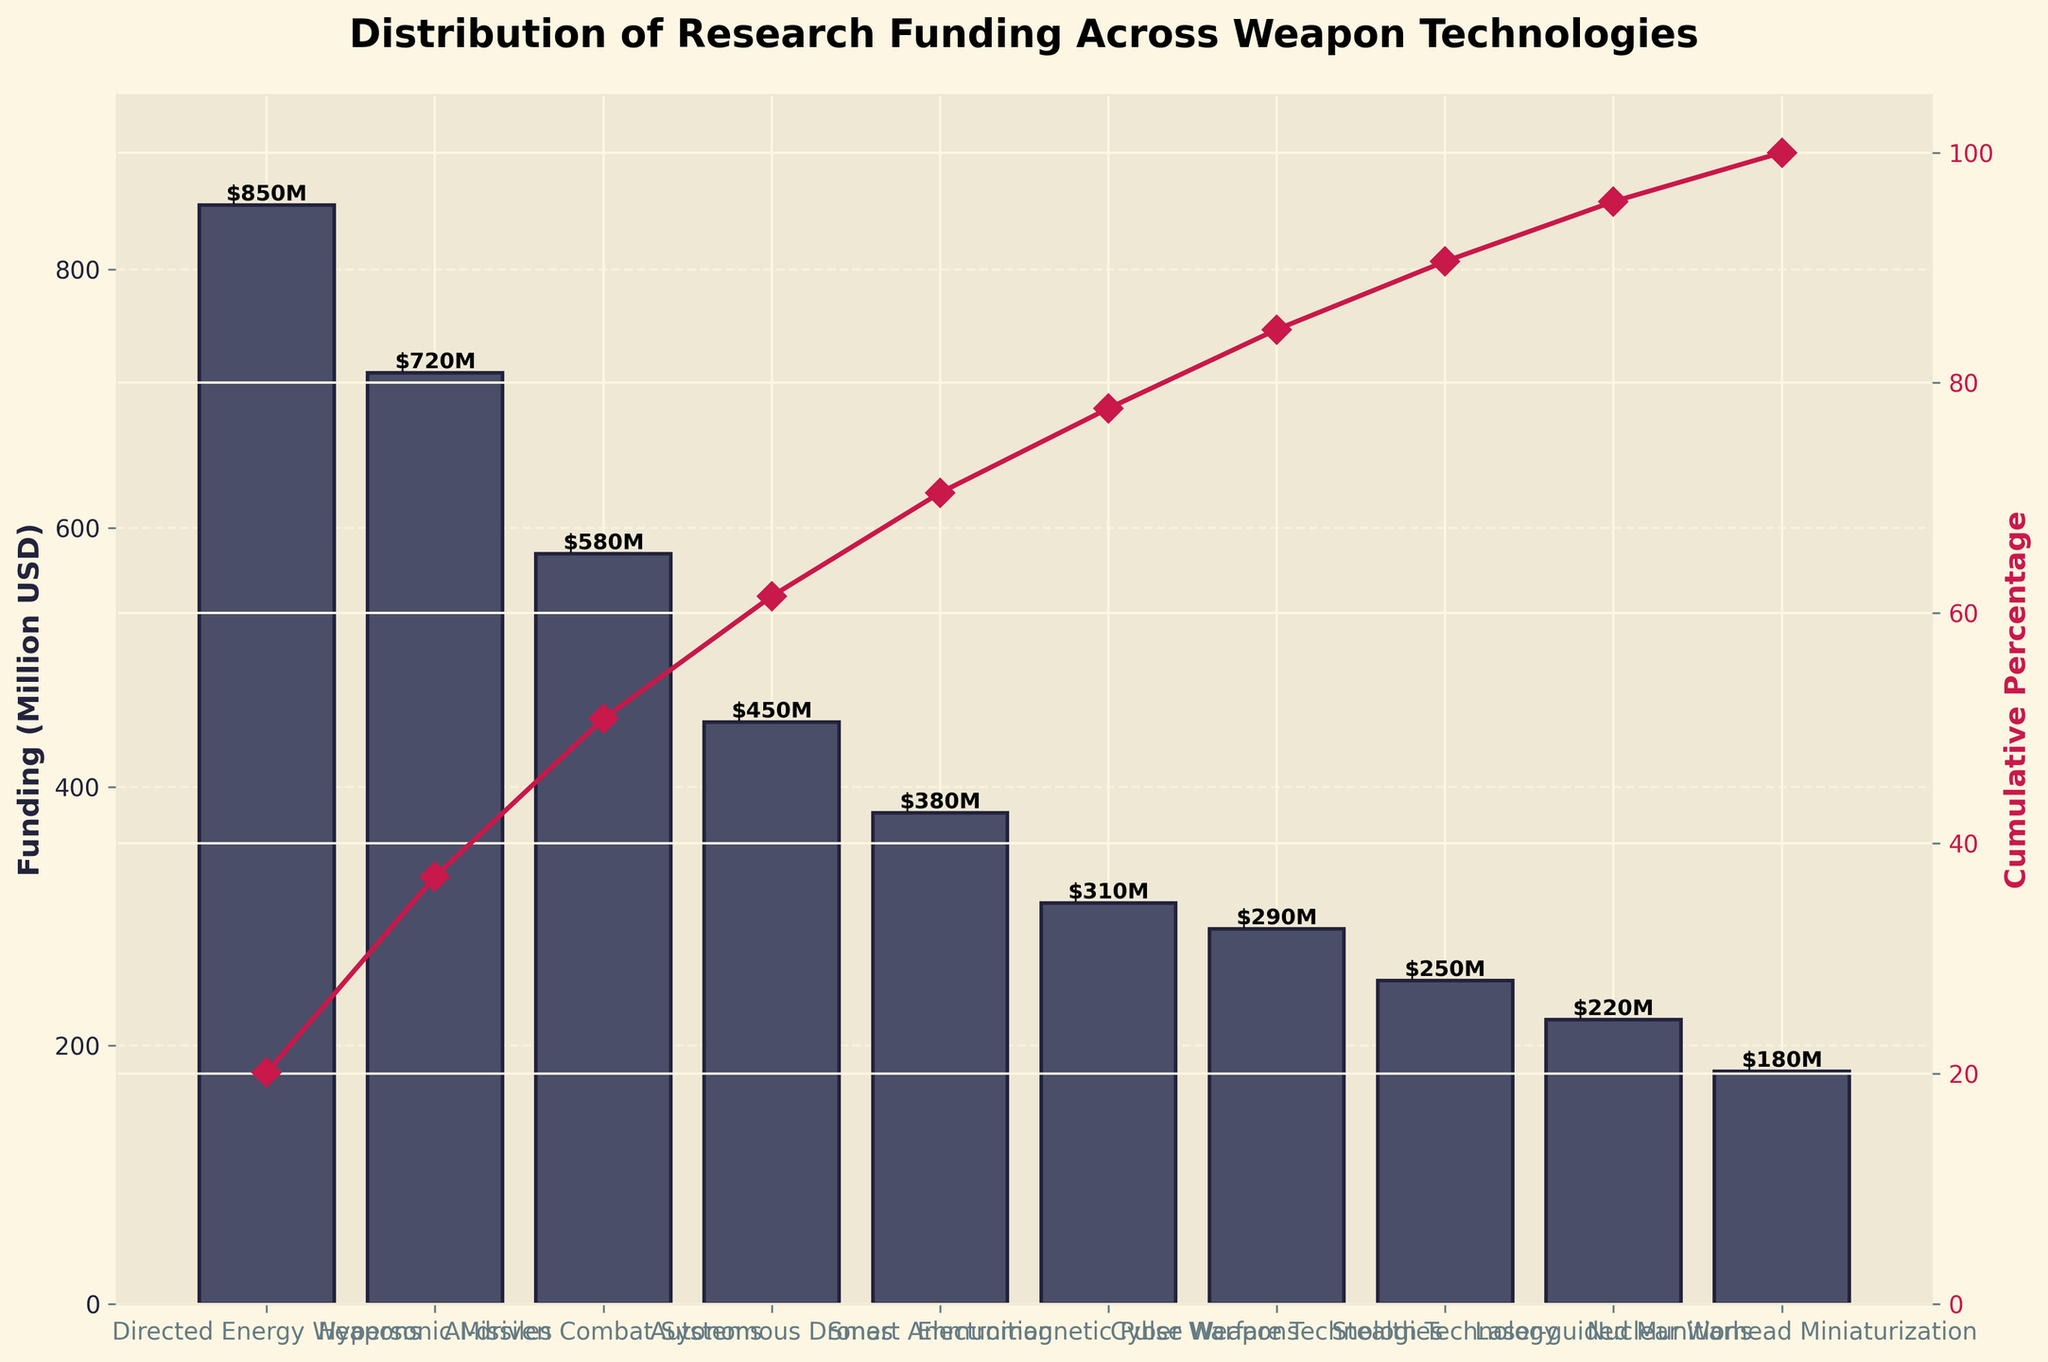what is the title of the figure? The title is usually placed at the top of the figure, and it provides a brief description of what the figure represents. In this case, it describes the distribution of research funding across various weapon technologies.
Answer: Distribution of Research Funding Across Weapon Technologies what is the total research funding represented in the chart? To find the total research funding, sum the values of funding for each weapon technology listed in the chart. The values are 850 + 720 + 580 + 450 + 380 + 310 + 290 + 250 + 220 + 180 = 4230 Million USD.
Answer: 4230 Million USD which weapon technology received the highest funding? The weapon technology with the highest bar in the chart represents the highest funding. In this figure, the highest bar corresponds to Directed Energy Weapons, which received 850 Million USD.
Answer: Directed Energy Weapons What percentage of the total funding is dedicated to the top three technologies? Identify the top three categories which got the highest funds: Directed Energy Weapons (850), Hypersonic Missiles (720), and AI-driven Combat Systems (580). Then, calculate their sum: 850 + 720 + 580 = 2150. Finally, divide by the total funding and multiply by 100: (2150 / 4230) * 100 = 50.83%.
Answer: 50.83% how many technologies have cumulative funding up to 70% of the total funding? The cumulative percentage line can help determine this. By examining the secondary y-axis values, find the categories which cover up to 70%. Directed Energy Weapons, Hypersonic Missiles, AI-driven Combat Systems, Autonomous Drones, and Smart Ammunition together represent up to 68.82%, but adding Electromagnetic Pulse Weapons exceeds 70%.
Answer: 5 technologies which technology has a cumulative percentage just below 60%? The cumulative percentage line shows cumulative funding as percentages. Locate the category whose cumulative percentage is just below 60%. As per the chart, Autonomous Drones have a cumulative percentage of around 59.62%, making it just below 60%.
Answer: Autonomous Drones what is the average funding per technology? To find the average funding, divide the total research funding by the number of categories. The total funding is 4230 Million USD, and there are 10 categories. So, the average is 4230 / 10 = 423 Million USD.
Answer: 423 Million USD which technology received less funding between Cyber Warfare Technologies and Stealth Technology? Compare the heights of the bars for Cyber Warfare Technologies (290 Million USD) and Stealth Technology (250 Million USD). The shorter bar represents less funding. Hence, Stealth Technology received less funding.
Answer: Stealth Technology how much more funding does Directed Energy Weapons receive than Nuclear Warhead Miniaturization? Subtract the funding for Nuclear Warhead Miniaturization (180 Million USD) from the funding for Directed Energy Weapons (850 Million USD), resulting in a difference of 850 - 180 = 670 Million USD.
Answer: 670 Million USD how does Smart Ammunition funding compare to AI-driven Combat Systems funding? Compare the values of Smart Ammunition (380 Million USD) and AI-driven Combat Systems (580 Million USD). By subtracting 380 from 580, it is evident that AI-driven Combat Systems received 200 Million USD more funding.
Answer: AI-driven Combat Systems received 200 Million USD more 